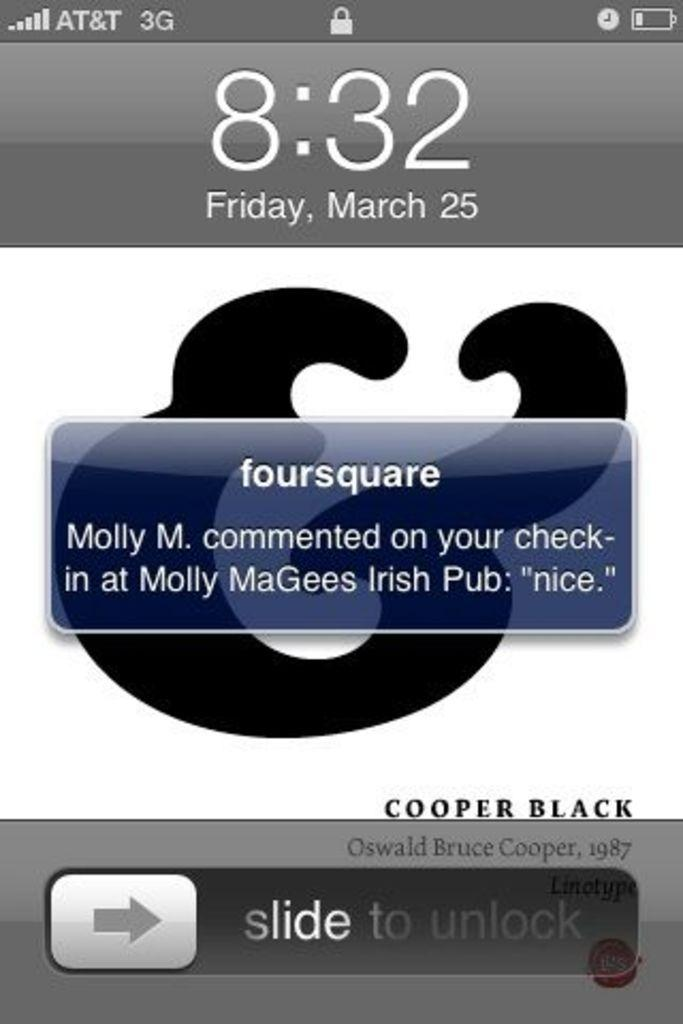<image>
Give a short and clear explanation of the subsequent image. The phone screen states that the time is currently 8:32. 